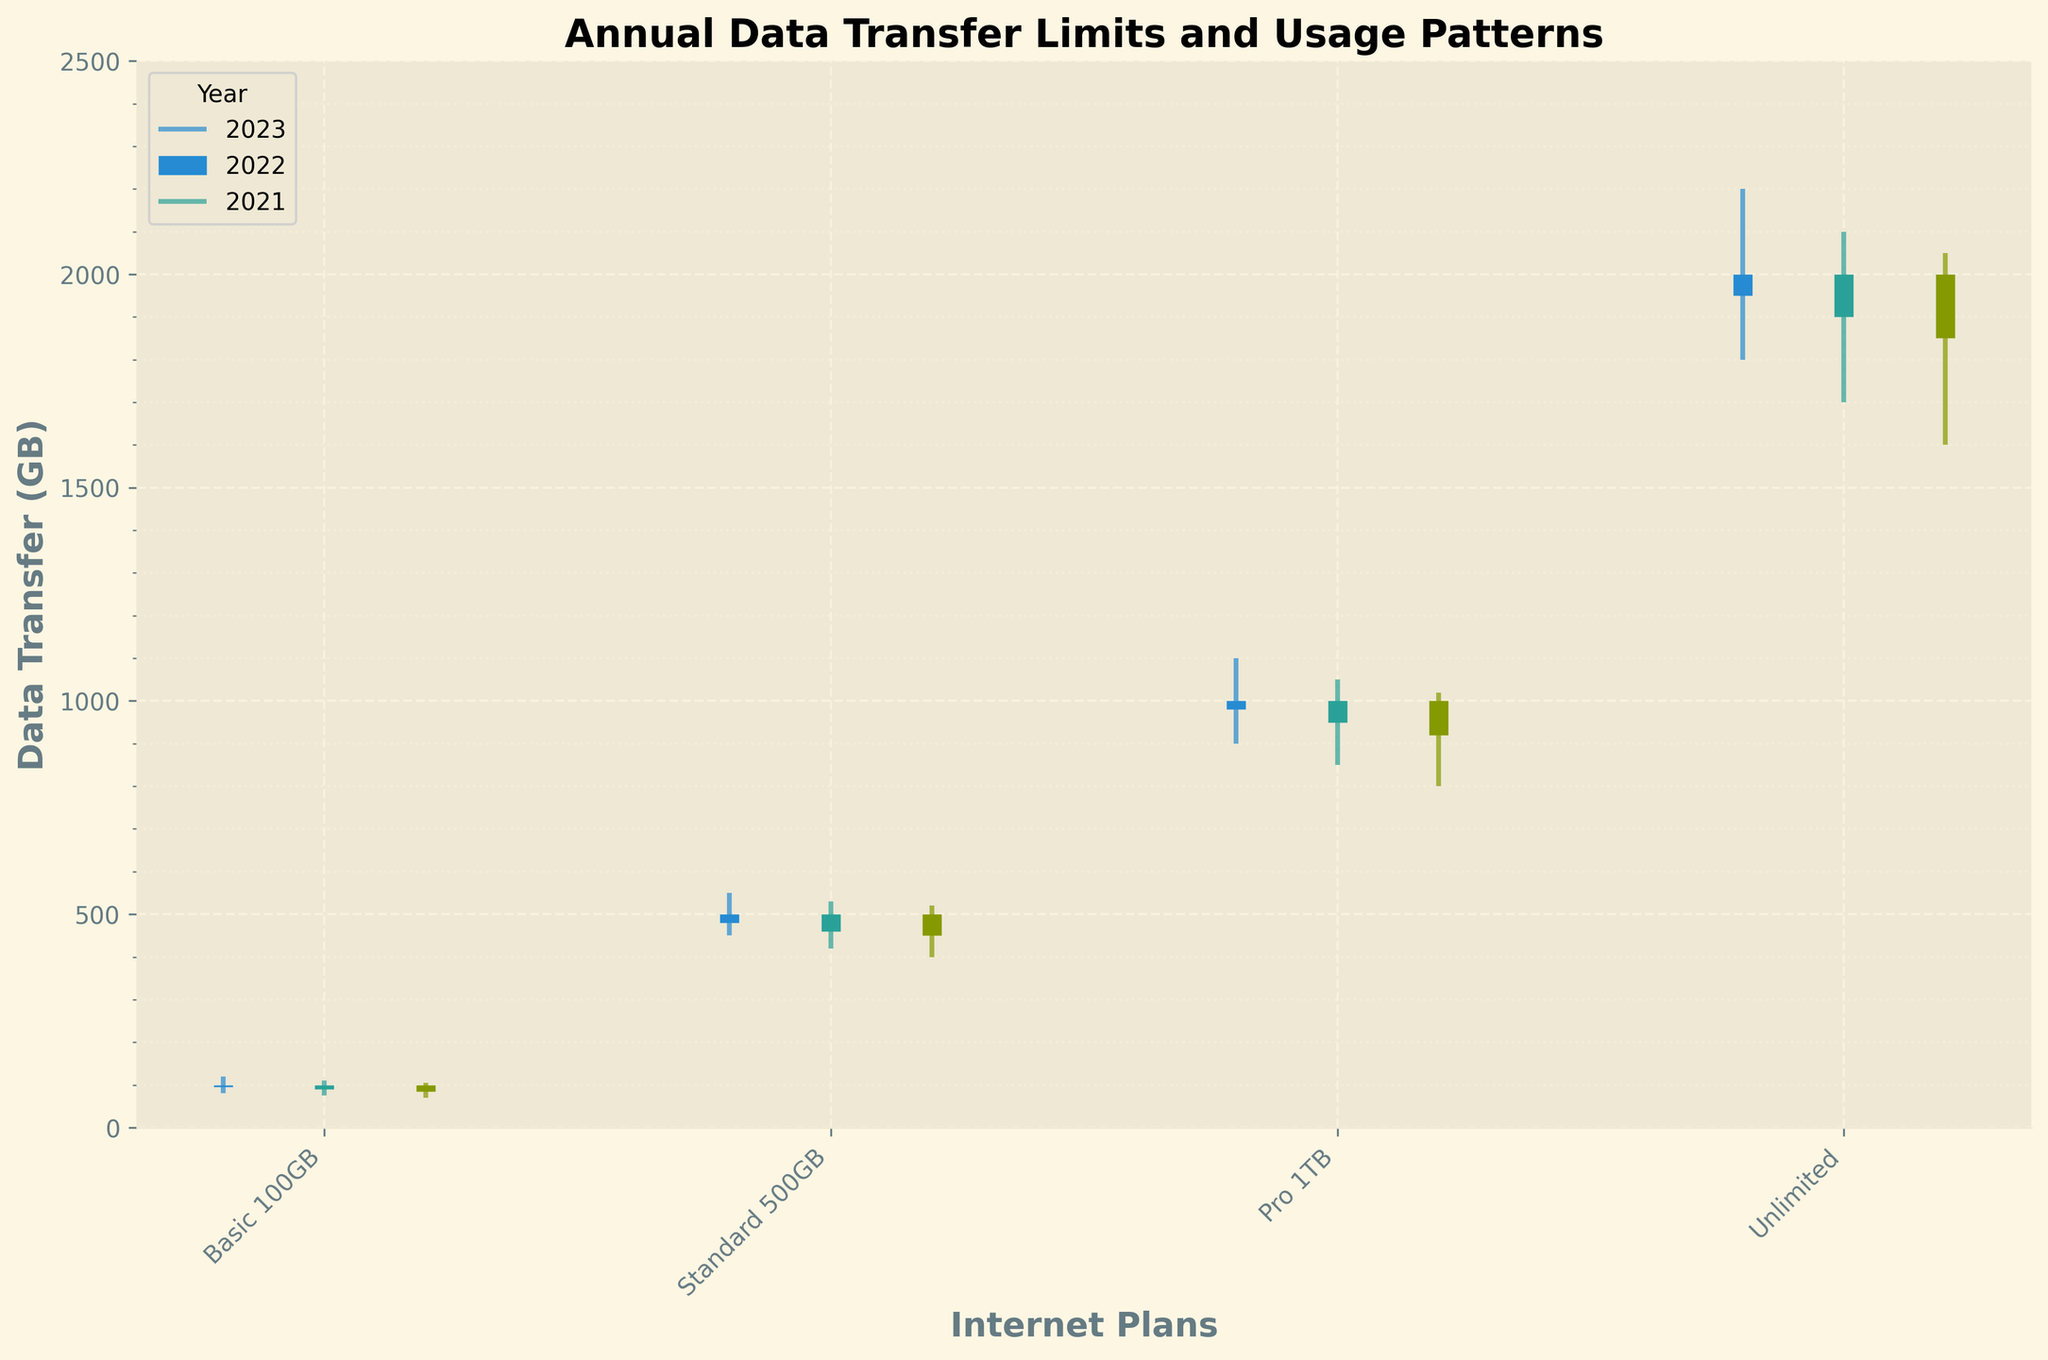What is the title of the figure? The title is located at the top of the figure and it describes what the figure is about. In this case, it is 'Annual Data Transfer Limits and Usage Patterns'.
Answer: Annual Data Transfer Limits and Usage Patterns How many internet plans are depicted in the figure? The number of internet plans can be determined from the x-axis labels. There are four labels: Basic 100GB, Standard 500GB, Pro 1TB, and Unlimited.
Answer: 4 What is the highest data transfer usage recorded for the Unlimited plan in 2023? The highest data transfer usage for each year is represented by the top end of the vertical lines (high value). For the Unlimited plan in 2023, it is 2200 GB.
Answer: 2200 GB Which internet plan had the lowest recorded data transfer in 2022? The lowest data transfer is represented by the bottom end of the vertical lines (low value). The Basic 100GB plan in 2022 had the lowest value of 75 GB.
Answer: Basic 100GB What was the data transfer range (difference between high and low values) for the Pro 1TB plan in 2023? The range can be calculated by subtracting the low value from the high value. For the Pro 1TB plan in 2023, it is 1100 - 900 = 200.
Answer: 200 GB Comparing the Standard 500GB plan, did the data transfer increase or decrease from 2022 to 2023? To determine this, compare the close values (end points of thicker lines) of the two years. The Standard 500GB plan closed at 460 GB in 2022 and 480 GB in 2023, so the data transfer increased.
Answer: Increased Which plan shows the smallest variation in data transfer usage in 2021? Variation can be determined by the distance between high and low values (shortest vertical line). The Basic 100GB plan in 2021 has the smallest variation with a range of 105 - 70 = 35.
Answer: Basic 100GB For the Unlimited plan, how much did the closed data transfer change between 2021 and 2023? Subtract the close value of 2021 from the close value of 2023 for the Unlimited plan. The change is 1950 (2023) - 1850 (2021) = 100.
Answer: 100 GB In which year did the Basic 100GB plan have the highest open value? The open value is represented by the bottom of the thick line. For the Basic 100GB plan, the highest open value (100 GB) was the same across all three years (2021, 2022, and 2023).
Answer: All years (2021, 2022, 2023) Which plan exhibits the largest data transfer fluctuation (difference between high and low values) across all years? The plan with the largest fluctuation will have the largest vertical line length. Across all years, the Unlimited plan shows the largest fluctuation, especially in 2023 with a range of 2200 - 1800 = 400.
Answer: Unlimited 